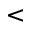<formula> <loc_0><loc_0><loc_500><loc_500><</formula> 